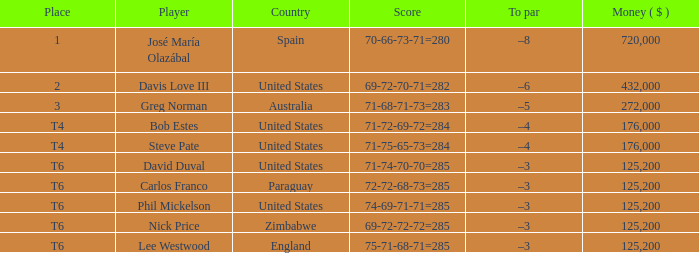Which Place has a To par of –8? 1.0. 